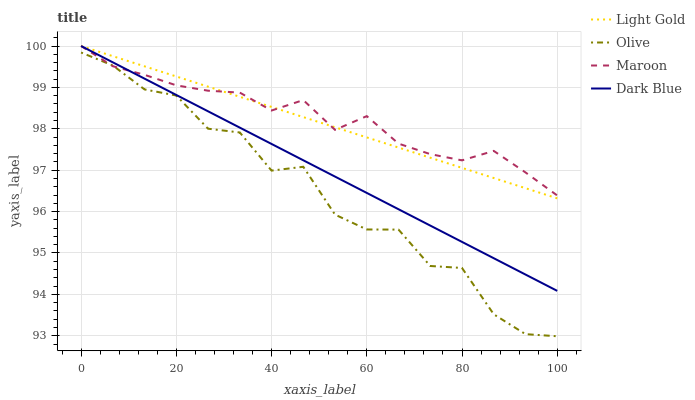Does Dark Blue have the minimum area under the curve?
Answer yes or no. No. Does Dark Blue have the maximum area under the curve?
Answer yes or no. No. Is Dark Blue the smoothest?
Answer yes or no. No. Is Dark Blue the roughest?
Answer yes or no. No. Does Dark Blue have the lowest value?
Answer yes or no. No. Is Olive less than Dark Blue?
Answer yes or no. Yes. Is Light Gold greater than Olive?
Answer yes or no. Yes. Does Olive intersect Dark Blue?
Answer yes or no. No. 